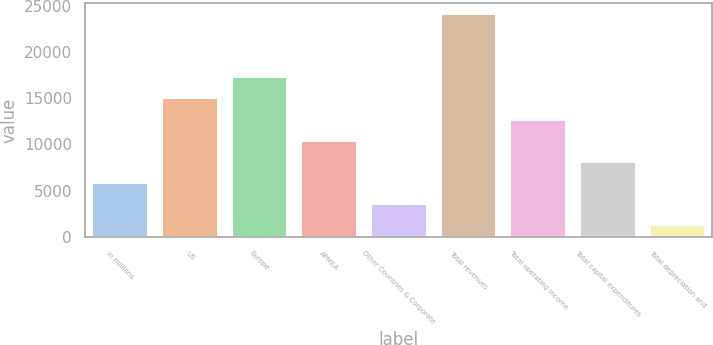Convert chart to OTSL. <chart><loc_0><loc_0><loc_500><loc_500><bar_chart><fcel>In millions<fcel>US<fcel>Europe<fcel>APMEA<fcel>Other Countries & Corporate<fcel>Total revenues<fcel>Total operating income<fcel>Total capital expenditures<fcel>Total depreciation and<nl><fcel>5835.88<fcel>14955.2<fcel>17235.1<fcel>10395.6<fcel>3556.04<fcel>24074.6<fcel>12675.4<fcel>8115.72<fcel>1276.2<nl></chart> 